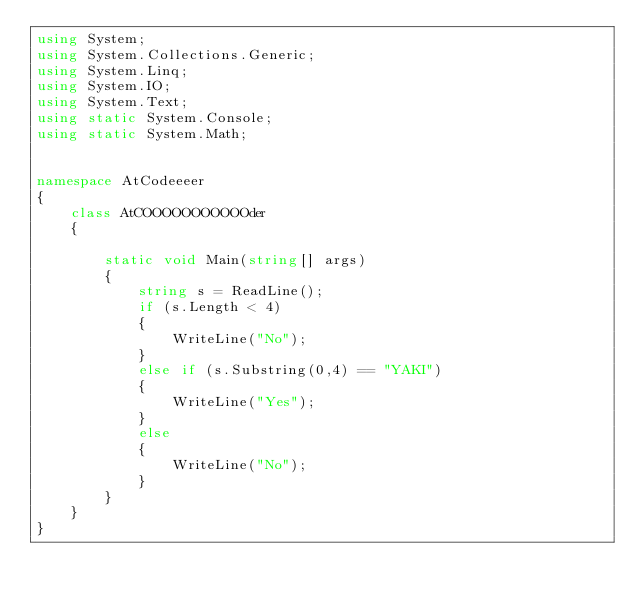<code> <loc_0><loc_0><loc_500><loc_500><_C#_>using System;
using System.Collections.Generic;
using System.Linq;
using System.IO;
using System.Text;
using static System.Console;
using static System.Math;


namespace AtCodeeeer
{
    class AtCOOOOOOOOOOOder
    { 
        
        static void Main(string[] args)
        {
            string s = ReadLine();
            if (s.Length < 4)
            {
                WriteLine("No");
            }
            else if (s.Substring(0,4) == "YAKI")
            {
                WriteLine("Yes");
            }
            else
            {
                WriteLine("No");
            }
        }
    }
}
</code> 